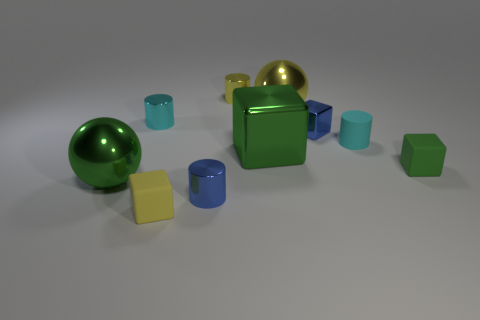Do the cyan metallic thing and the green cube that is to the left of the green rubber cube have the same size?
Give a very brief answer. No. There is a small cyan thing left of the blue block; what is its shape?
Provide a short and direct response. Cylinder. Is there a big green metal ball that is in front of the rubber object that is left of the tiny blue object that is on the left side of the blue block?
Your answer should be compact. No. There is another green object that is the same shape as the small green object; what is it made of?
Offer a terse response. Metal. Is there anything else that is the same material as the small blue cube?
Provide a short and direct response. Yes. What number of cubes are either large blue things or large metal things?
Your response must be concise. 1. Do the cyan cylinder that is right of the small metallic cube and the ball that is on the left side of the green shiny cube have the same size?
Offer a very short reply. No. What material is the cyan thing that is on the left side of the small shiny cylinder in front of the blue cube made of?
Ensure brevity in your answer.  Metal. Are there fewer blue cubes in front of the blue block than blocks?
Keep it short and to the point. Yes. What is the shape of the cyan thing that is the same material as the large green block?
Give a very brief answer. Cylinder. 